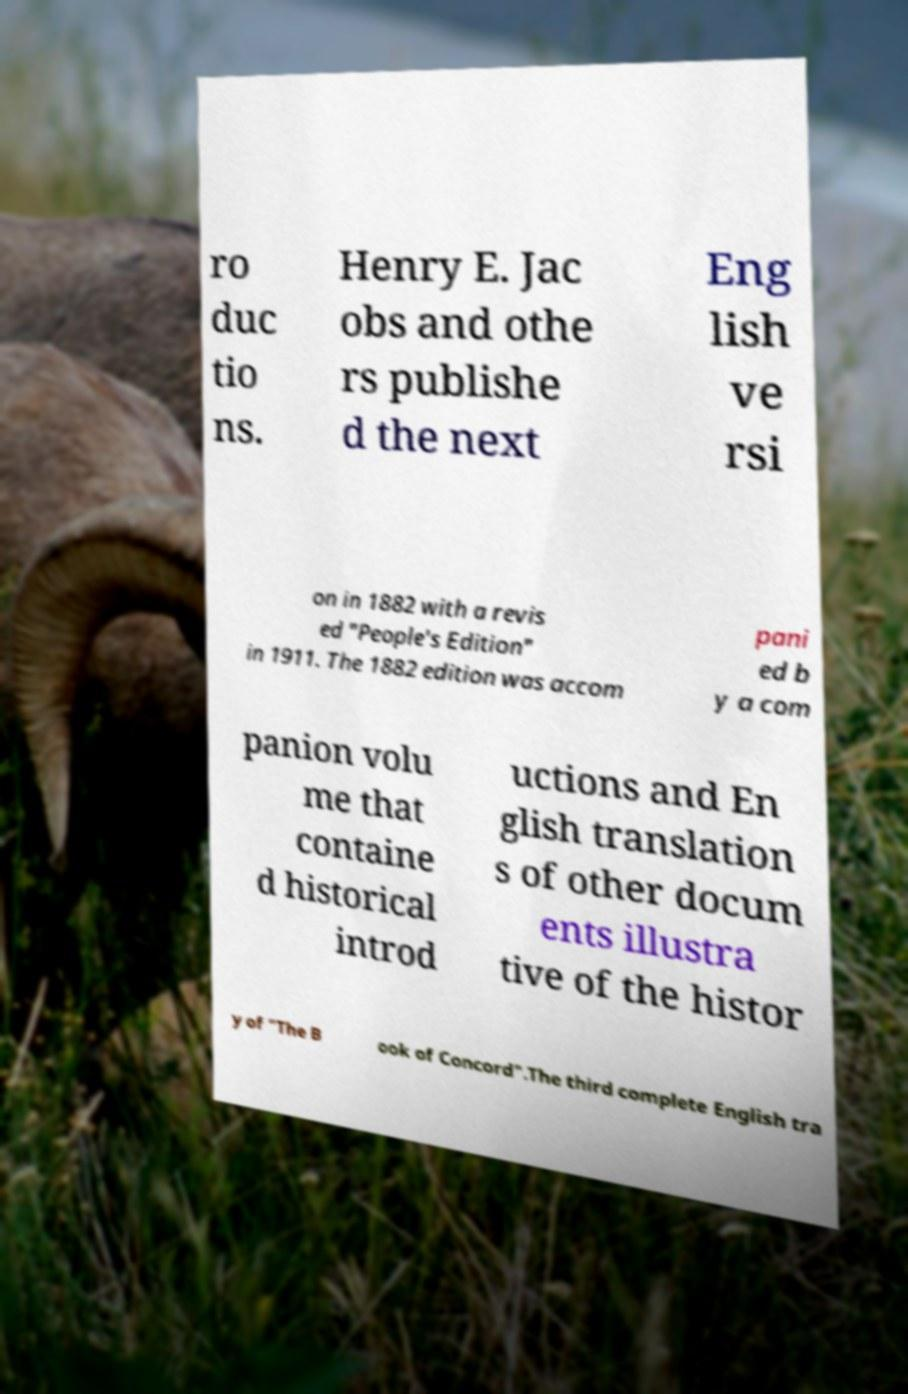I need the written content from this picture converted into text. Can you do that? ro duc tio ns. Henry E. Jac obs and othe rs publishe d the next Eng lish ve rsi on in 1882 with a revis ed "People's Edition" in 1911. The 1882 edition was accom pani ed b y a com panion volu me that containe d historical introd uctions and En glish translation s of other docum ents illustra tive of the histor y of "The B ook of Concord".The third complete English tra 